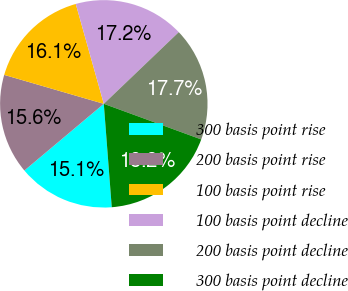Convert chart to OTSL. <chart><loc_0><loc_0><loc_500><loc_500><pie_chart><fcel>300 basis point rise<fcel>200 basis point rise<fcel>100 basis point rise<fcel>100 basis point decline<fcel>200 basis point decline<fcel>300 basis point decline<nl><fcel>15.1%<fcel>15.62%<fcel>16.14%<fcel>17.21%<fcel>17.72%<fcel>18.2%<nl></chart> 